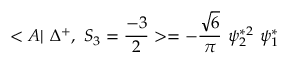Convert formula to latex. <formula><loc_0><loc_0><loc_500><loc_500>< A | \Delta ^ { + } , S _ { 3 } = \frac { - 3 } { 2 } > = - \frac { \sqrt { 6 } } { \pi } \psi _ { 2 } ^ { * 2 } \psi _ { 1 } ^ { * }</formula> 